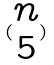Convert formula to latex. <formula><loc_0><loc_0><loc_500><loc_500>( \begin{matrix} n \\ 5 \end{matrix} )</formula> 